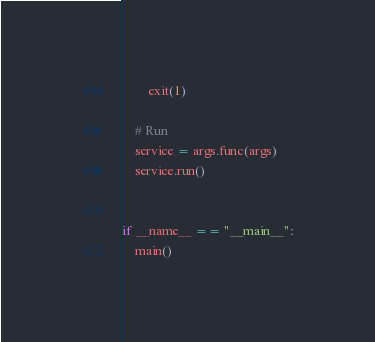<code> <loc_0><loc_0><loc_500><loc_500><_Python_>        exit(1)

    # Run
    service = args.func(args)
    service.run()


if __name__ == "__main__":
    main()
</code> 